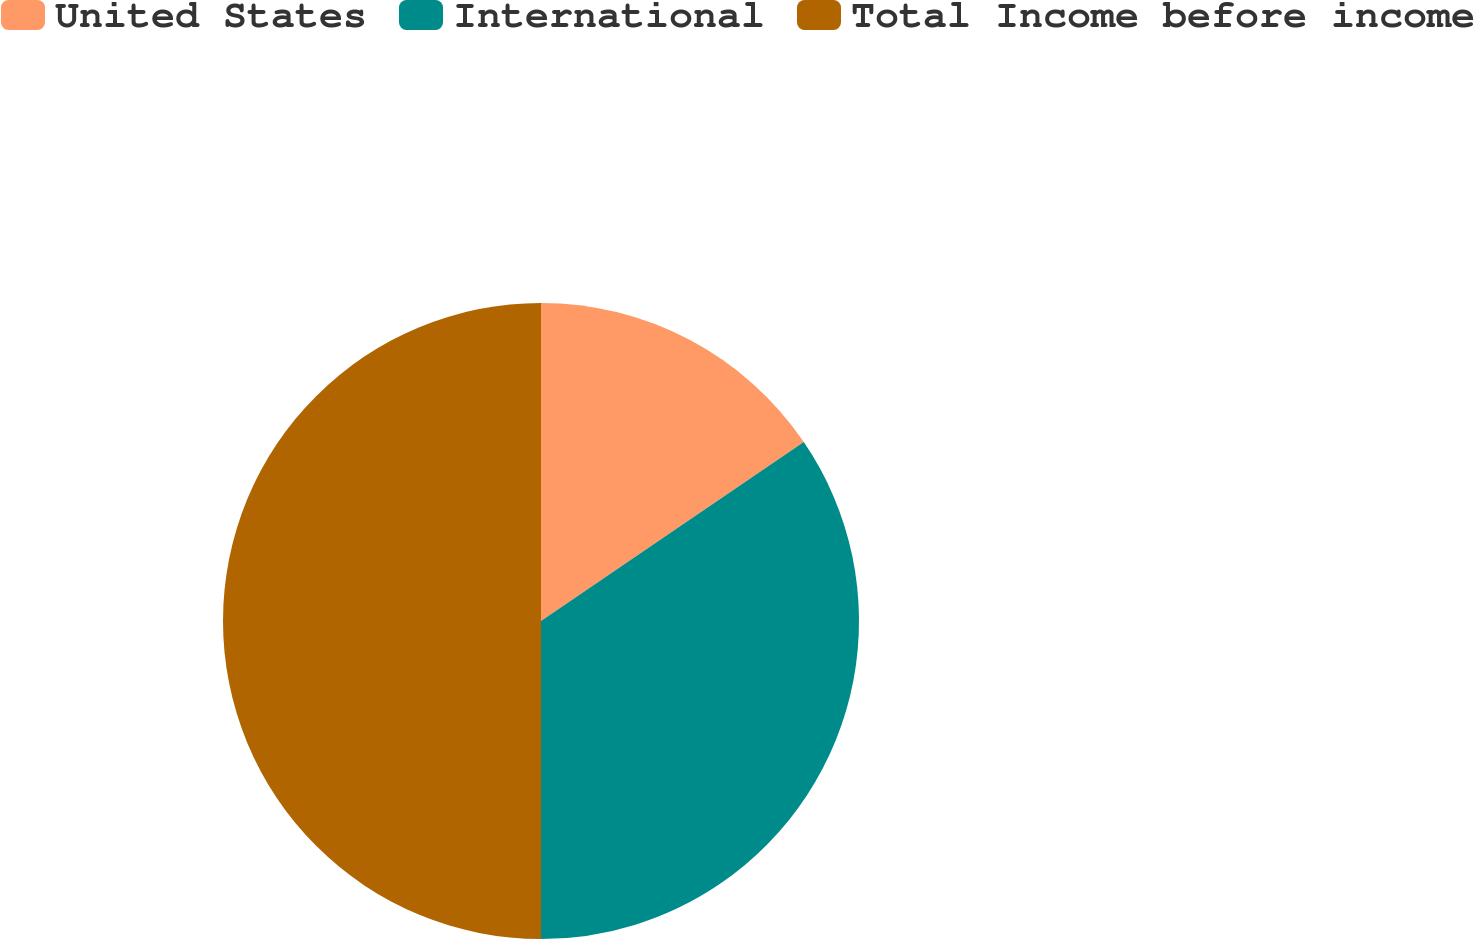Convert chart. <chart><loc_0><loc_0><loc_500><loc_500><pie_chart><fcel>United States<fcel>International<fcel>Total Income before income<nl><fcel>15.48%<fcel>34.52%<fcel>50.0%<nl></chart> 